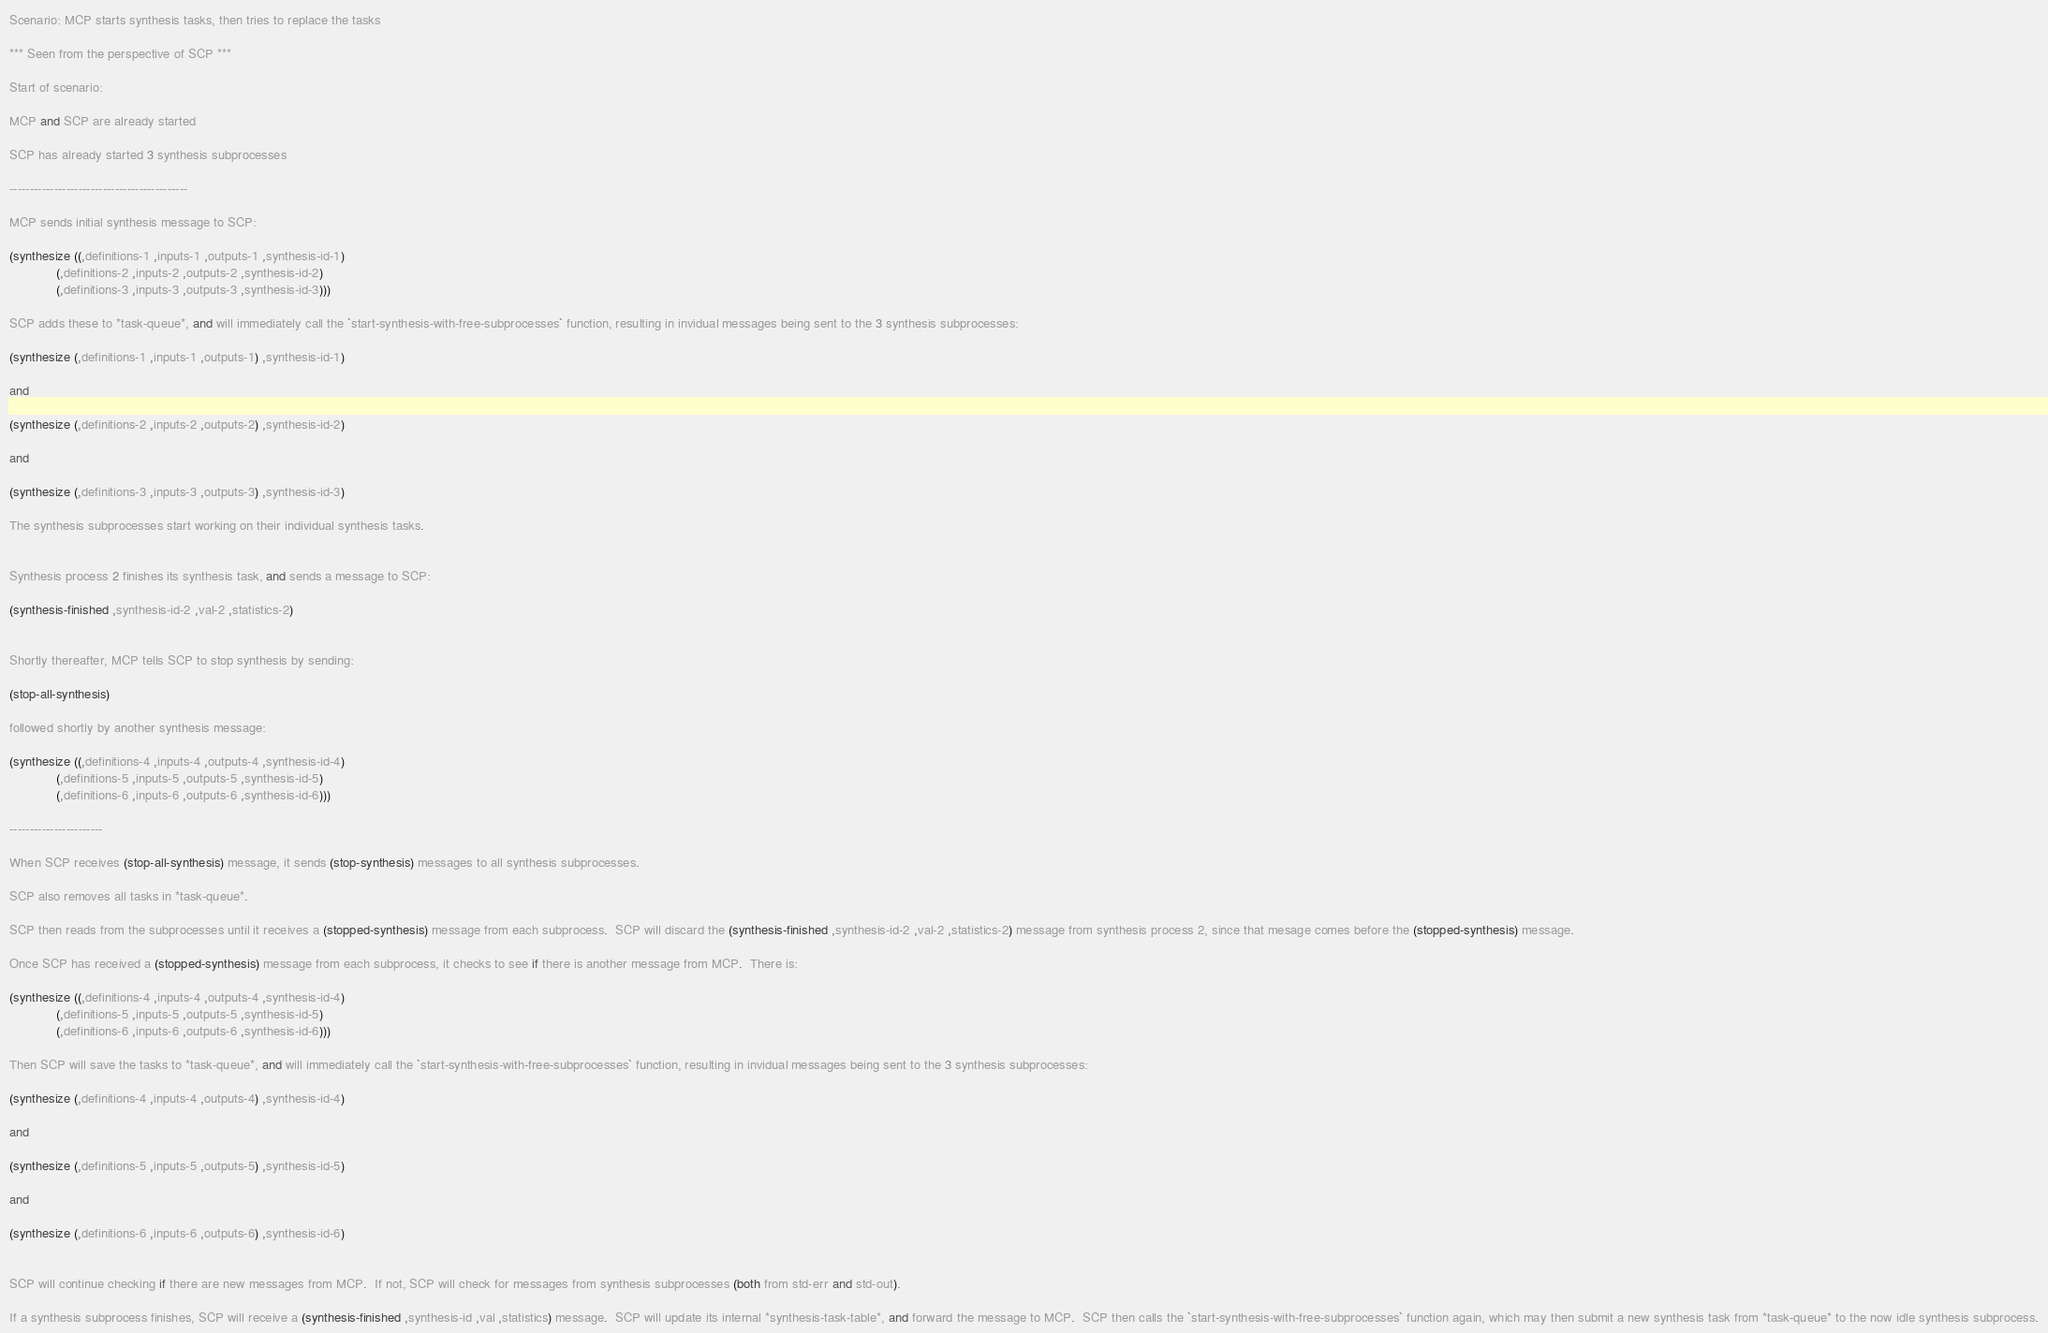<code> <loc_0><loc_0><loc_500><loc_500><_Scheme_>Scenario: MCP starts synthesis tasks, then tries to replace the tasks

*** Seen from the perspective of SCP ***

Start of scenario:

MCP and SCP are already started

SCP has already started 3 synthesis subprocesses

--------------------------------------------

MCP sends initial synthesis message to SCP:

(synthesize ((,definitions-1 ,inputs-1 ,outputs-1 ,synthesis-id-1)
             (,definitions-2 ,inputs-2 ,outputs-2 ,synthesis-id-2)
             (,definitions-3 ,inputs-3 ,outputs-3 ,synthesis-id-3)))

SCP adds these to *task-queue*, and will immediately call the `start-synthesis-with-free-subprocesses` function, resulting in invidual messages being sent to the 3 synthesis subprocesses:

(synthesize (,definitions-1 ,inputs-1 ,outputs-1) ,synthesis-id-1)

and

(synthesize (,definitions-2 ,inputs-2 ,outputs-2) ,synthesis-id-2)

and

(synthesize (,definitions-3 ,inputs-3 ,outputs-3) ,synthesis-id-3)

The synthesis subprocesses start working on their individual synthesis tasks.


Synthesis process 2 finishes its synthesis task, and sends a message to SCP:

(synthesis-finished ,synthesis-id-2 ,val-2 ,statistics-2)


Shortly thereafter, MCP tells SCP to stop synthesis by sending:

(stop-all-synthesis)

followed shortly by another synthesis message:

(synthesize ((,definitions-4 ,inputs-4 ,outputs-4 ,synthesis-id-4)
             (,definitions-5 ,inputs-5 ,outputs-5 ,synthesis-id-5)
             (,definitions-6 ,inputs-6 ,outputs-6 ,synthesis-id-6)))

-----------------------

When SCP receives (stop-all-synthesis) message, it sends (stop-synthesis) messages to all synthesis subprocesses.

SCP also removes all tasks in *task-queue*.

SCP then reads from the subprocesses until it receives a (stopped-synthesis) message from each subprocess.  SCP will discard the (synthesis-finished ,synthesis-id-2 ,val-2 ,statistics-2) message from synthesis process 2, since that mesage comes before the (stopped-synthesis) message.

Once SCP has received a (stopped-synthesis) message from each subprocess, it checks to see if there is another message from MCP.  There is:

(synthesize ((,definitions-4 ,inputs-4 ,outputs-4 ,synthesis-id-4)
             (,definitions-5 ,inputs-5 ,outputs-5 ,synthesis-id-5)
             (,definitions-6 ,inputs-6 ,outputs-6 ,synthesis-id-6)))

Then SCP will save the tasks to *task-queue*, and will immediately call the `start-synthesis-with-free-subprocesses` function, resulting in invidual messages being sent to the 3 synthesis subprocesses:

(synthesize (,definitions-4 ,inputs-4 ,outputs-4) ,synthesis-id-4)

and

(synthesize (,definitions-5 ,inputs-5 ,outputs-5) ,synthesis-id-5)

and

(synthesize (,definitions-6 ,inputs-6 ,outputs-6) ,synthesis-id-6)


SCP will continue checking if there are new messages from MCP.  If not, SCP will check for messages from synthesis subprocesses (both from std-err and std-out).

If a synthesis subprocess finishes, SCP will receive a (synthesis-finished ,synthesis-id ,val ,statistics) message.  SCP will update its internal *synthesis-task-table*, and forward the message to MCP.  SCP then calls the `start-synthesis-with-free-subprocesses` function again, which may then submit a new synthesis task from *task-queue* to the now idle synthesis subprocess.
</code> 